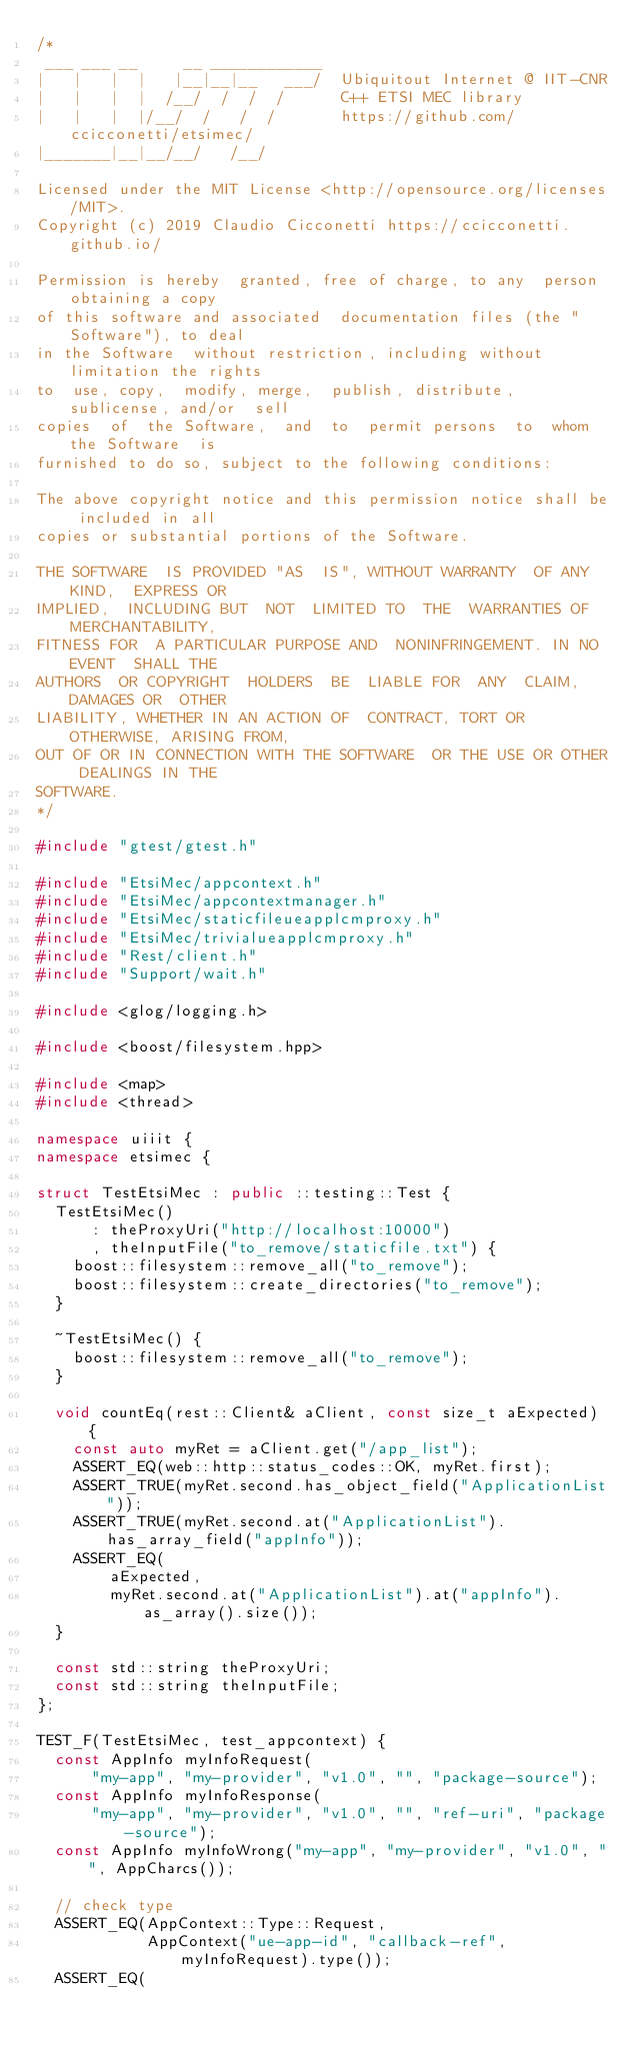<code> <loc_0><loc_0><loc_500><loc_500><_C++_>/*
 ___ ___ __     __ ____________
|   |   |  |   |__|__|__   ___/  Ubiquitout Internet @ IIT-CNR
|   |   |  |  /__/  /  /  /      C++ ETSI MEC library
|   |   |  |/__/  /   /  /       https://github.com/ccicconetti/etsimec/
|_______|__|__/__/   /__/

Licensed under the MIT License <http://opensource.org/licenses/MIT>.
Copyright (c) 2019 Claudio Cicconetti https://ccicconetti.github.io/

Permission is hereby  granted, free of charge, to any  person obtaining a copy
of this software and associated  documentation files (the "Software"), to deal
in the Software  without restriction, including without  limitation the rights
to  use, copy,  modify, merge,  publish, distribute,  sublicense, and/or  sell
copies  of  the Software,  and  to  permit persons  to  whom  the Software  is
furnished to do so, subject to the following conditions:

The above copyright notice and this permission notice shall be included in all
copies or substantial portions of the Software.

THE SOFTWARE  IS PROVIDED "AS  IS", WITHOUT WARRANTY  OF ANY KIND,  EXPRESS OR
IMPLIED,  INCLUDING BUT  NOT  LIMITED TO  THE  WARRANTIES OF  MERCHANTABILITY,
FITNESS FOR  A PARTICULAR PURPOSE AND  NONINFRINGEMENT. IN NO EVENT  SHALL THE
AUTHORS  OR COPYRIGHT  HOLDERS  BE  LIABLE FOR  ANY  CLAIM,  DAMAGES OR  OTHER
LIABILITY, WHETHER IN AN ACTION OF  CONTRACT, TORT OR OTHERWISE, ARISING FROM,
OUT OF OR IN CONNECTION WITH THE SOFTWARE  OR THE USE OR OTHER DEALINGS IN THE
SOFTWARE.
*/

#include "gtest/gtest.h"

#include "EtsiMec/appcontext.h"
#include "EtsiMec/appcontextmanager.h"
#include "EtsiMec/staticfileueapplcmproxy.h"
#include "EtsiMec/trivialueapplcmproxy.h"
#include "Rest/client.h"
#include "Support/wait.h"

#include <glog/logging.h>

#include <boost/filesystem.hpp>

#include <map>
#include <thread>

namespace uiiit {
namespace etsimec {

struct TestEtsiMec : public ::testing::Test {
  TestEtsiMec()
      : theProxyUri("http://localhost:10000")
      , theInputFile("to_remove/staticfile.txt") {
    boost::filesystem::remove_all("to_remove");
    boost::filesystem::create_directories("to_remove");
  }

  ~TestEtsiMec() {
    boost::filesystem::remove_all("to_remove");
  }

  void countEq(rest::Client& aClient, const size_t aExpected) {
    const auto myRet = aClient.get("/app_list");
    ASSERT_EQ(web::http::status_codes::OK, myRet.first);
    ASSERT_TRUE(myRet.second.has_object_field("ApplicationList"));
    ASSERT_TRUE(myRet.second.at("ApplicationList").has_array_field("appInfo"));
    ASSERT_EQ(
        aExpected,
        myRet.second.at("ApplicationList").at("appInfo").as_array().size());
  }

  const std::string theProxyUri;
  const std::string theInputFile;
};

TEST_F(TestEtsiMec, test_appcontext) {
  const AppInfo myInfoRequest(
      "my-app", "my-provider", "v1.0", "", "package-source");
  const AppInfo myInfoResponse(
      "my-app", "my-provider", "v1.0", "", "ref-uri", "package-source");
  const AppInfo myInfoWrong("my-app", "my-provider", "v1.0", "", AppCharcs());

  // check type
  ASSERT_EQ(AppContext::Type::Request,
            AppContext("ue-app-id", "callback-ref", myInfoRequest).type());
  ASSERT_EQ(</code> 